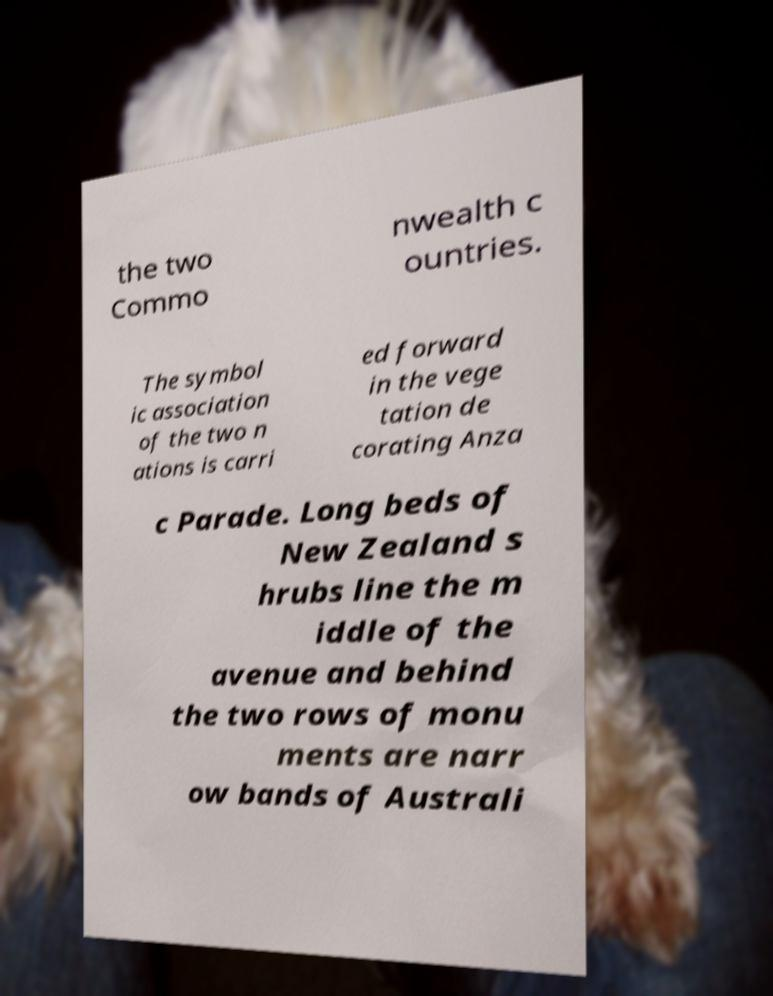Can you read and provide the text displayed in the image?This photo seems to have some interesting text. Can you extract and type it out for me? the two Commo nwealth c ountries. The symbol ic association of the two n ations is carri ed forward in the vege tation de corating Anza c Parade. Long beds of New Zealand s hrubs line the m iddle of the avenue and behind the two rows of monu ments are narr ow bands of Australi 